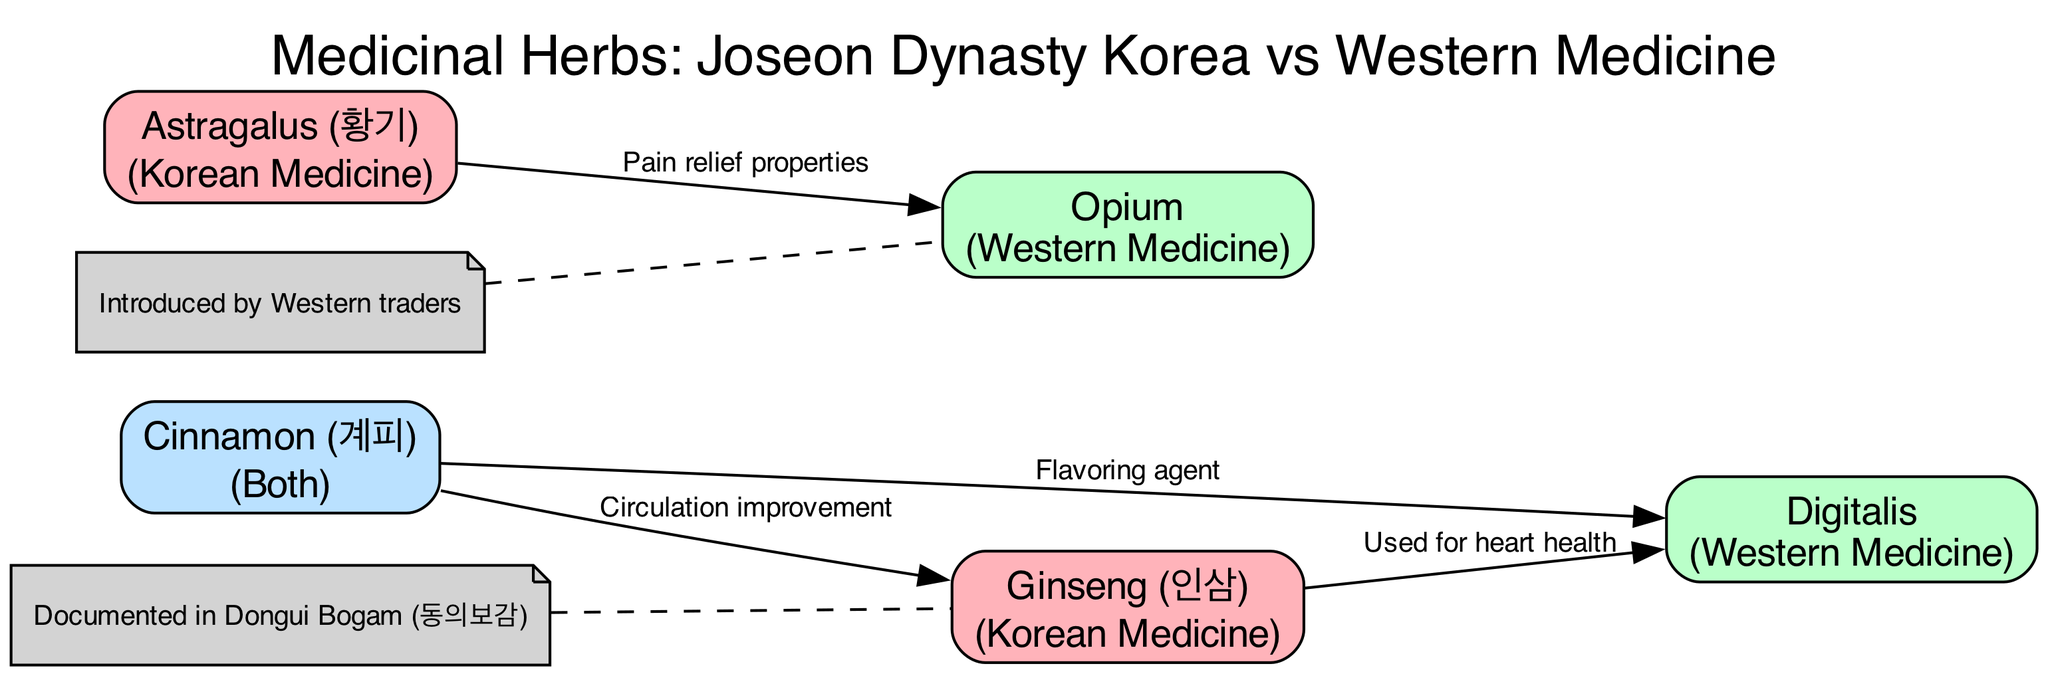What is the name of the Korean medicinal herb shown in the diagram? The diagram lists several medicinal herbs, and one of them categorized as Korean Medicine is Ginseng (인삼). This is indicated in the nodes section of the diagram.
Answer: Ginseng (인삼) Which Western medicinal herb is used for pain relief properties? In the edges section of the diagram, the relationship between Astragalus (황기) and Opium is labeled with "Pain relief properties." Therefore, the Western herb Opium is associated with pain relief.
Answer: Opium How many nodes are there in total in the diagram? The nodes section of the diagram lists five distinct medicinal herbs. To find the total, we simply count the number provided in that section.
Answer: 5 What is the color representing Korean Medicine in the diagram? The diagram specifies colors for different categories. Korean Medicine is represented in light pink (#FFB3BA) for its nodes, as indicated in the corresponding section.
Answer: Light pink What herb serves as both a Korean and Western medicinal herb? The node for Cinnamon (계피) is categorized as "Both," meaning it is used in both Korean and Western medicine as mentioned in the nodes section.
Answer: Cinnamon (계피) Which medicinal herbs are linked together by the edge labeled "Used for heart health"? The edge between Ginseng (인삼) and Digitalis connects them with the label "Used for heart health." This indicates that these two herbs have a shared use in heart health within traditional practices.
Answer: Ginseng (인삼) and Digitalis What documented traditional text is associated with Ginseng? The diagram provides annotations indicating that Ginseng (인삼) is documented in Dongui Bogam (동의보감), pointing directly to the source of this knowledge.
Answer: Dongui Bogam (동의보감) How does Cinnamon (계피) relate to Ginseng (인삼) based on the edges? The edge labeled "Circulation improvement" indicates that Cinnamon (계피) has a direct relationship with Ginseng (인삼) regarding health benefits related to circulation. Thus, they are directly connected through this function.
Answer: Circulation improvement How is Opium described in the context of its introduction? The annotation note linked to Opium states that it was "Introduced by Western traders," providing insight into its historical context as noted in the diagram.
Answer: Introduced by Western traders 